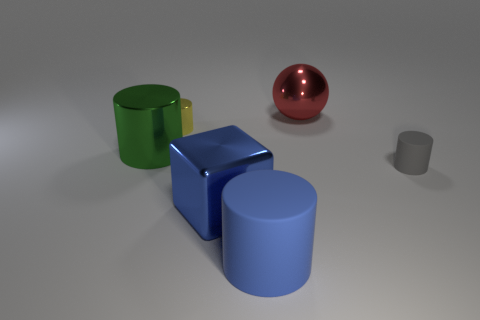Add 4 big blue metallic objects. How many objects exist? 10 Subtract all blocks. How many objects are left? 5 Add 1 big green metal cylinders. How many big green metal cylinders are left? 2 Add 4 tiny purple cylinders. How many tiny purple cylinders exist? 4 Subtract 0 blue spheres. How many objects are left? 6 Subtract all gray cylinders. Subtract all red spheres. How many objects are left? 4 